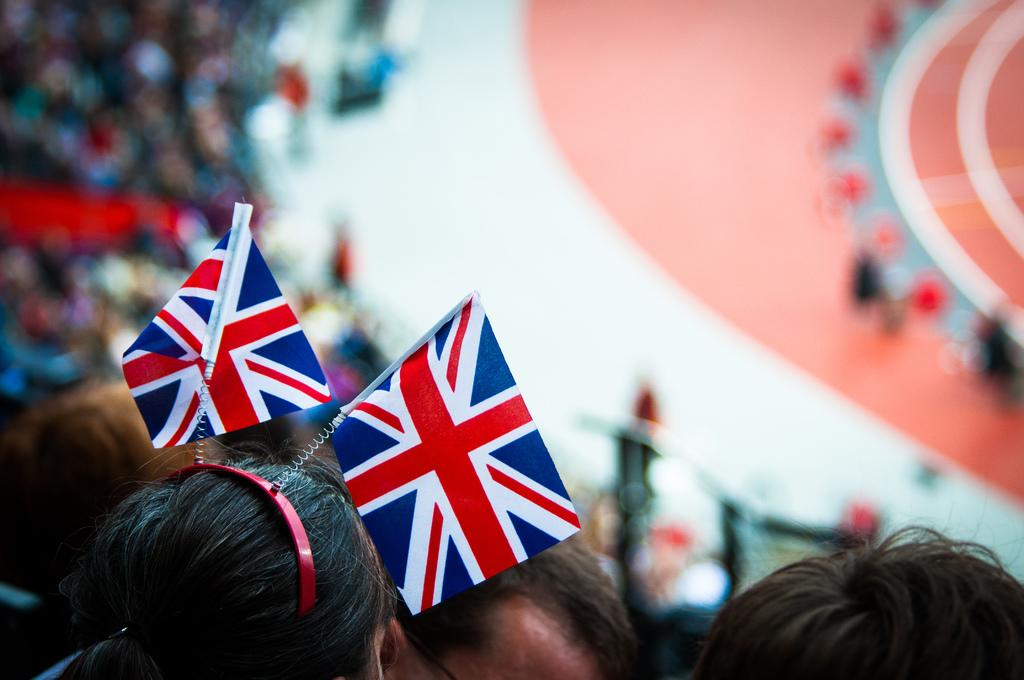How many people are in the image? There are people in the image. Can you describe the headwear of one of the people? One person is wearing flag headwear. What can be said about the background of the image? The background is blurred. What news is being reported by the lamp in the image? There is no lamp present in the image, and therefore no news can be reported by it. 